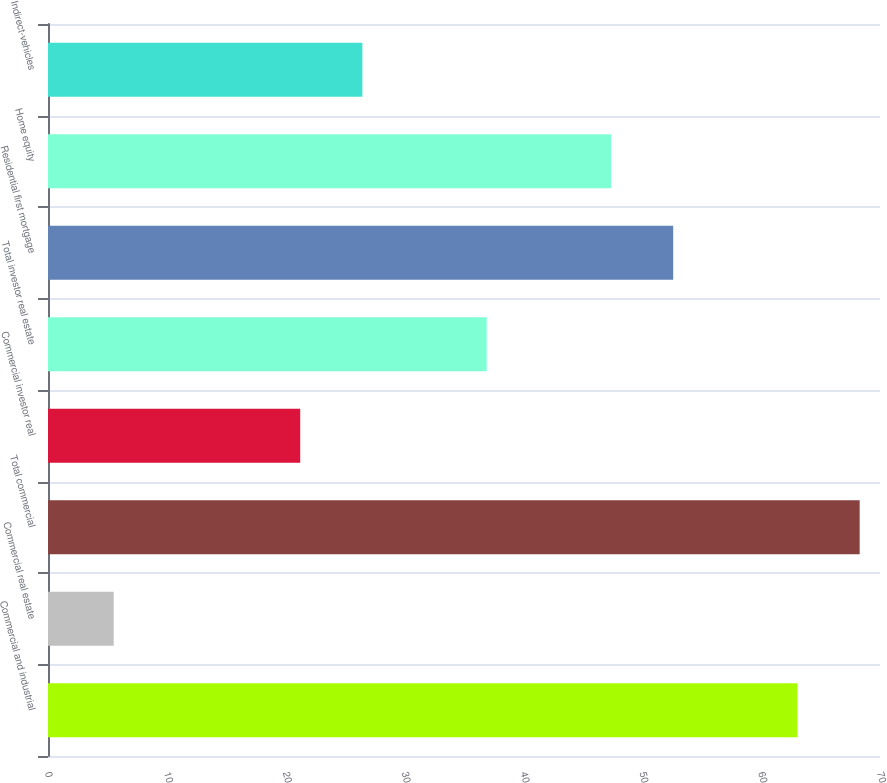Convert chart. <chart><loc_0><loc_0><loc_500><loc_500><bar_chart><fcel>Commercial and industrial<fcel>Commercial real estate<fcel>Total commercial<fcel>Commercial investor real<fcel>Total investor real estate<fcel>Residential first mortgage<fcel>Home equity<fcel>Indirect-vehicles<nl><fcel>63.06<fcel>5.53<fcel>68.29<fcel>21.22<fcel>36.91<fcel>52.6<fcel>47.37<fcel>26.45<nl></chart> 